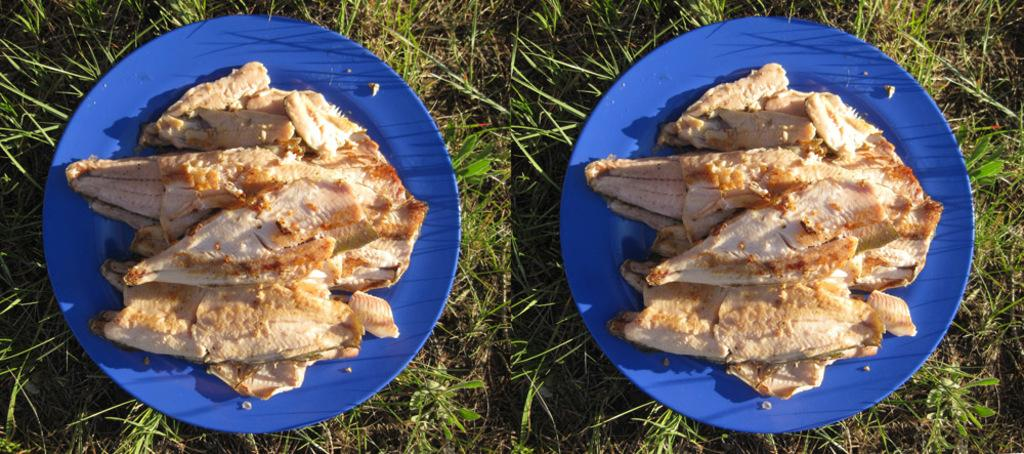What type of artwork is depicted in the image? The image is a collage. What type of food can be seen in the image? There is meat in the image. How is the meat presented in the image? The meat is placed on a plate. What type of leather can be seen in the image? There is no leather present in the image; it features a collage with meat on a plate. What scent is associated with the meat in the image? The image is a visual representation and does not convey scents, so we cannot determine the scent of the meat. 